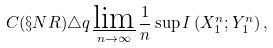Convert formula to latex. <formula><loc_0><loc_0><loc_500><loc_500>C ( \S N R ) \triangle q \varliminf _ { n \to \infty } \frac { 1 } { n } \sup I \left ( X _ { 1 } ^ { n } ; Y _ { 1 } ^ { n } \right ) ,</formula> 